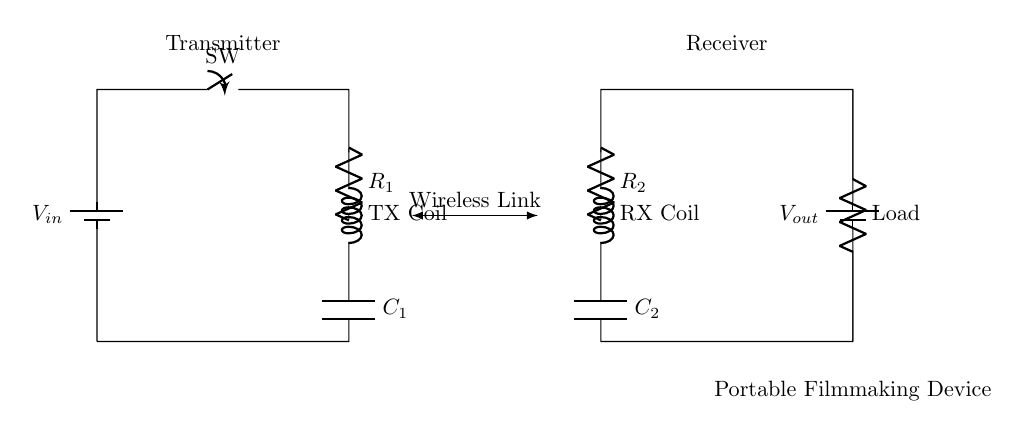What is the input voltage? The circuit shows a battery with the label V\_in, indicating the input voltage source. The voltage isn't specified numerically, but it typically could be any standard battery voltage.
Answer: V_in What components are present in the transmitter side? The transmitter side includes a battery, a switch, an inductor labeled TX Coil, a resistor labeled R1, and a capacitor labeled C1.
Answer: Battery, switch, TX Coil, R1, C1 What is the purpose of the load in this circuit? The load component, placed at the end of the receiver side, represents the actual portable filmmaking device that will utilize the power transmitted wirelessly.
Answer: Powering device What is the relationship between the TX Coil and RX Coil? The TX Coil and RX Coil create a wireless link between the transmitter and receiver sides, allowing for power transfer through electromagnetic induction.
Answer: Wireless power transfer How does the capacitor C1 affect the circuit performance? C1 in the transmitter side is used for filtering and stabilizing the voltage by smoothing the electric current, which can affect efficiency and performance in power transfer.
Answer: Stabilizes voltage What type of circuit is this? This circuit is a wireless power transfer circuit designed to charge a portable filmmaking device without the need for direct electrical connections.
Answer: Wireless power transfer circuit What is the function of the switch in the circuit? The switch allows for controlling the circuit by enabling or disabling the flow of current from the input voltage source to the TX Coil, thus controlling the operation of the transmitter.
Answer: Controls current flow 